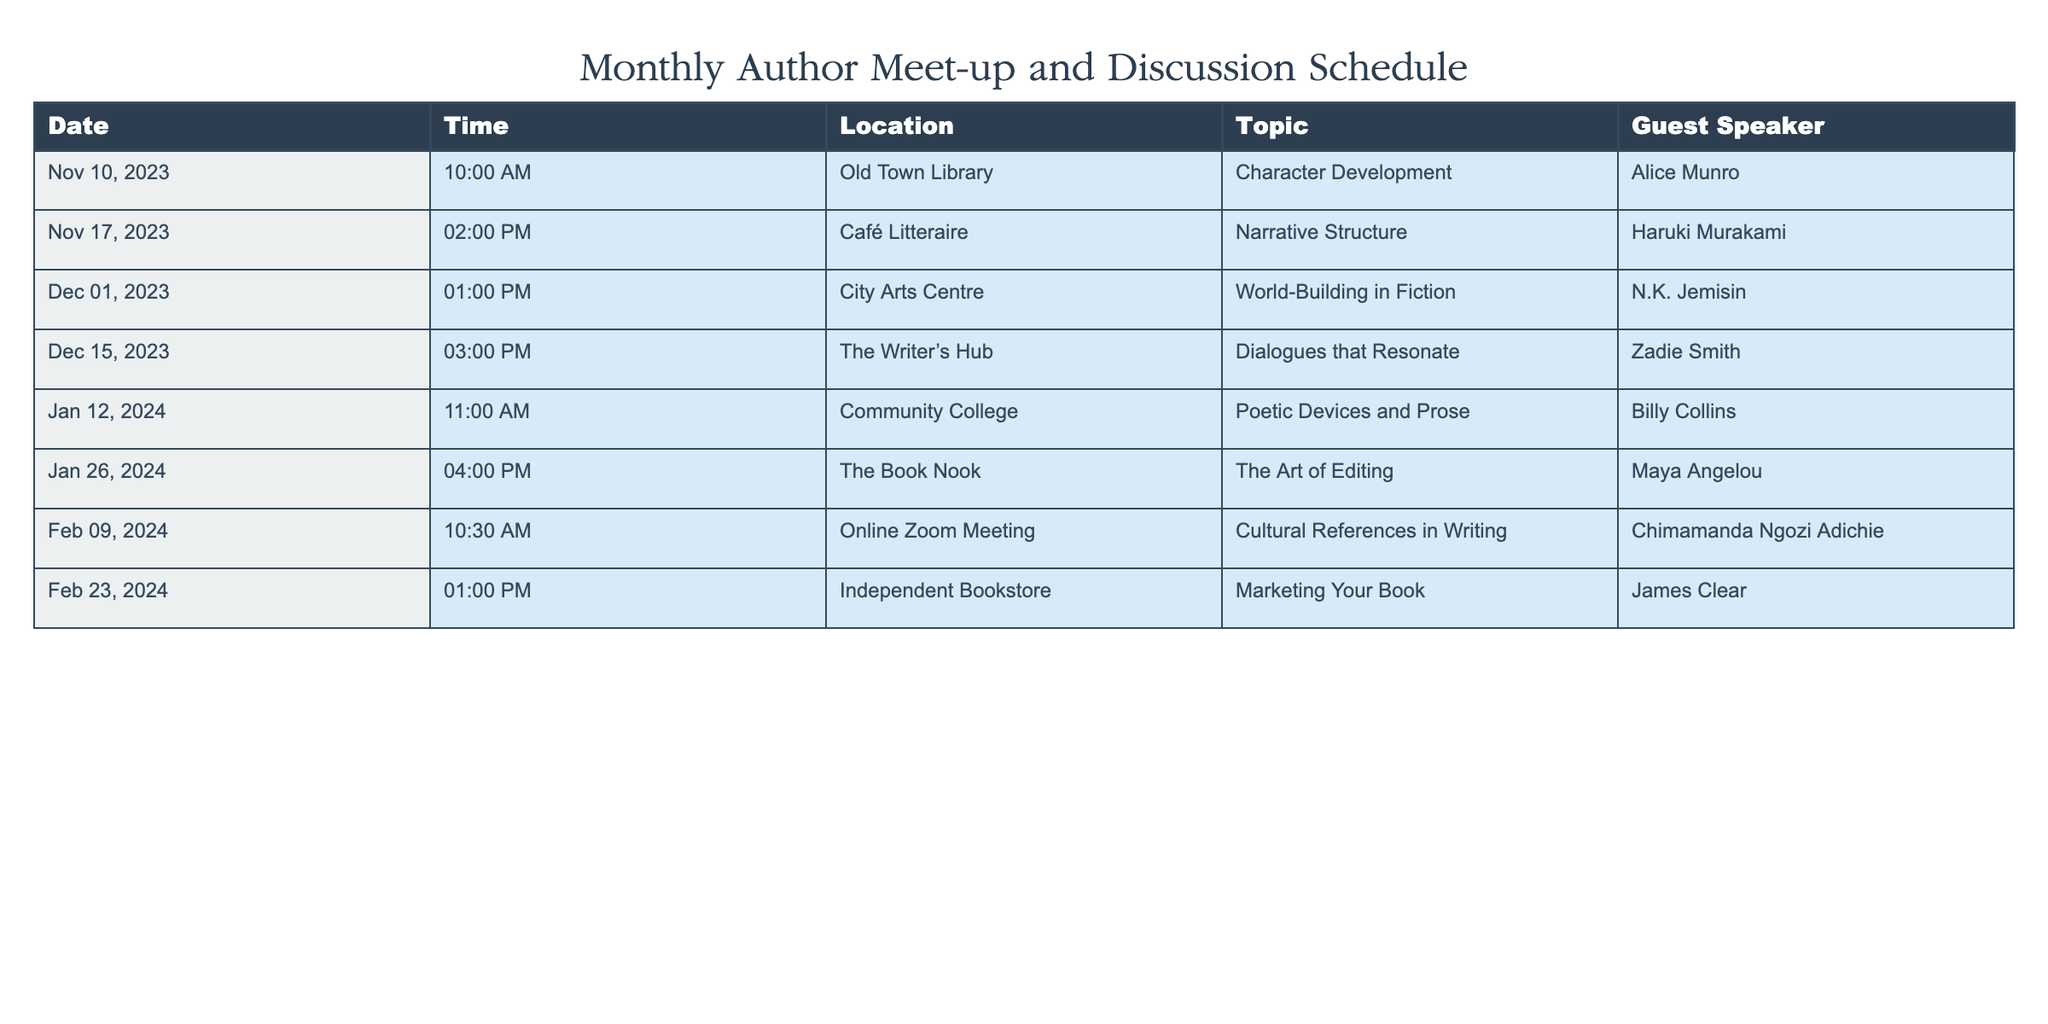What date is the author meet-up focused on "Character Development"? The table lists different sessions, and the topic of "Character Development" corresponds to the first entry. The date listed for this session is November 10, 2023.
Answer: November 10, 2023 Who is the guest speaker at the meet-up on "Narrative Structure"? Looking through the table, the session related to "Narrative Structure" is on November 17, 2023, and the guest speaker listed for this topic is Haruki Murakami.
Answer: Haruki Murakami How many meet-ups are scheduled in December 2023? The table shows two entries for December 2023: one on December 1 and another on December 15. Therefore, there are two meet-ups scheduled for that month.
Answer: 2 Is there a meet-up scheduled online? The table indicates that there is an online Zoom meeting on February 9, 2024. This suggests there is indeed a session that is not held in person.
Answer: Yes Which topic has the latest scheduled time in the next three months? The next three months include November 2023, December 2023, and January 2024. The meeting with the latest time is on January 26, 2024, at 4:00 PM, discussing "The Art of Editing."
Answer: The Art of Editing What is the total number of topics being discussed in the first quarter of 2024 (January to March)? Checking the timeline for January to March 2024, there are three sessions: January 12, January 26, and February 9. All these sessions discuss unique topics. Therefore, there are three topics during this time frame.
Answer: 3 Who speaks on "World-Building in Fiction"? Referring to the table, the session on "World-Building in Fiction" takes place on December 1, 2023, with guest speaker N.K. Jemisin.
Answer: N.K. Jemisin On what days of the week do the meet-ups in December 2023 occur? The two dates in December are December 1 (Friday) and December 15 (Friday). Therefore, both meet-ups fall on a Friday.
Answer: Friday What is the average time of the meet-ups scheduled in January 2024? We have two meet-ups in January: January 12 at 11:00 AM and January 26 at 4:00 PM. Converting times to hours, 11:00 AM equals 11, and 4:00 PM equals 16, the average is (11 + 16) / 2 = 13.5 hours, which is 1:30 PM.
Answer: 1:30 PM 